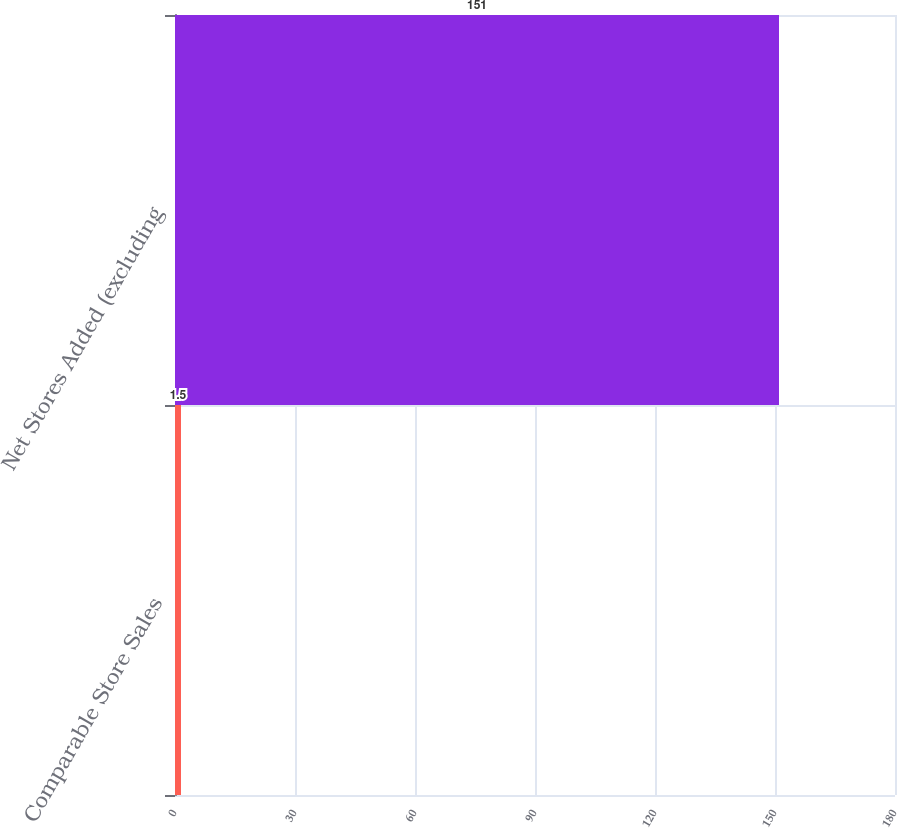Convert chart. <chart><loc_0><loc_0><loc_500><loc_500><bar_chart><fcel>Comparable Store Sales<fcel>Net Stores Added (excluding<nl><fcel>1.5<fcel>151<nl></chart> 